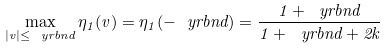Convert formula to latex. <formula><loc_0><loc_0><loc_500><loc_500>\max _ { | v | \leq \ y r b n d } \eta _ { 1 } ( v ) = \eta _ { 1 } ( - \ y r b n d ) = \frac { 1 + \ y r b n d } { 1 + \ y r b n d + 2 k }</formula> 